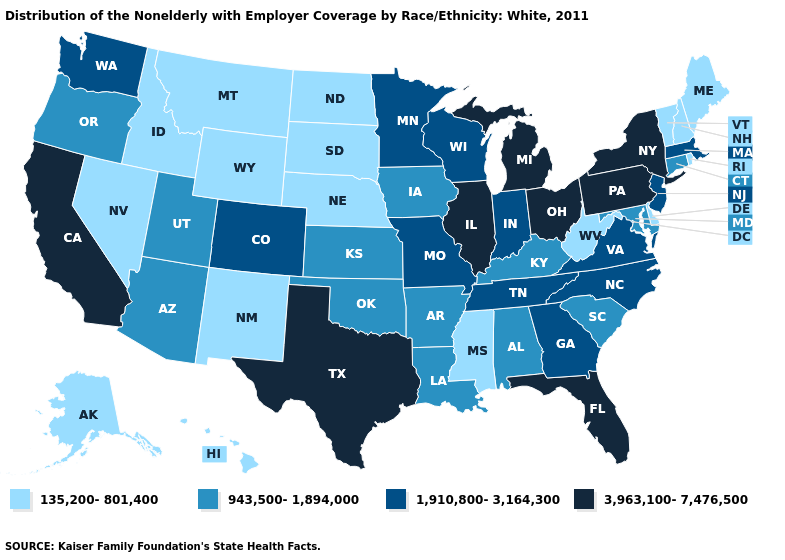What is the value of Colorado?
Quick response, please. 1,910,800-3,164,300. What is the value of Maine?
Be succinct. 135,200-801,400. Name the states that have a value in the range 135,200-801,400?
Answer briefly. Alaska, Delaware, Hawaii, Idaho, Maine, Mississippi, Montana, Nebraska, Nevada, New Hampshire, New Mexico, North Dakota, Rhode Island, South Dakota, Vermont, West Virginia, Wyoming. Does Delaware have the highest value in the USA?
Keep it brief. No. Does Maine have the highest value in the Northeast?
Short answer required. No. Is the legend a continuous bar?
Quick response, please. No. Which states hav the highest value in the South?
Concise answer only. Florida, Texas. Name the states that have a value in the range 135,200-801,400?
Answer briefly. Alaska, Delaware, Hawaii, Idaho, Maine, Mississippi, Montana, Nebraska, Nevada, New Hampshire, New Mexico, North Dakota, Rhode Island, South Dakota, Vermont, West Virginia, Wyoming. What is the value of New Mexico?
Keep it brief. 135,200-801,400. Name the states that have a value in the range 943,500-1,894,000?
Quick response, please. Alabama, Arizona, Arkansas, Connecticut, Iowa, Kansas, Kentucky, Louisiana, Maryland, Oklahoma, Oregon, South Carolina, Utah. How many symbols are there in the legend?
Concise answer only. 4. How many symbols are there in the legend?
Write a very short answer. 4. Does Utah have the lowest value in the West?
Quick response, please. No. Does North Dakota have the lowest value in the USA?
Answer briefly. Yes. Name the states that have a value in the range 943,500-1,894,000?
Be succinct. Alabama, Arizona, Arkansas, Connecticut, Iowa, Kansas, Kentucky, Louisiana, Maryland, Oklahoma, Oregon, South Carolina, Utah. 